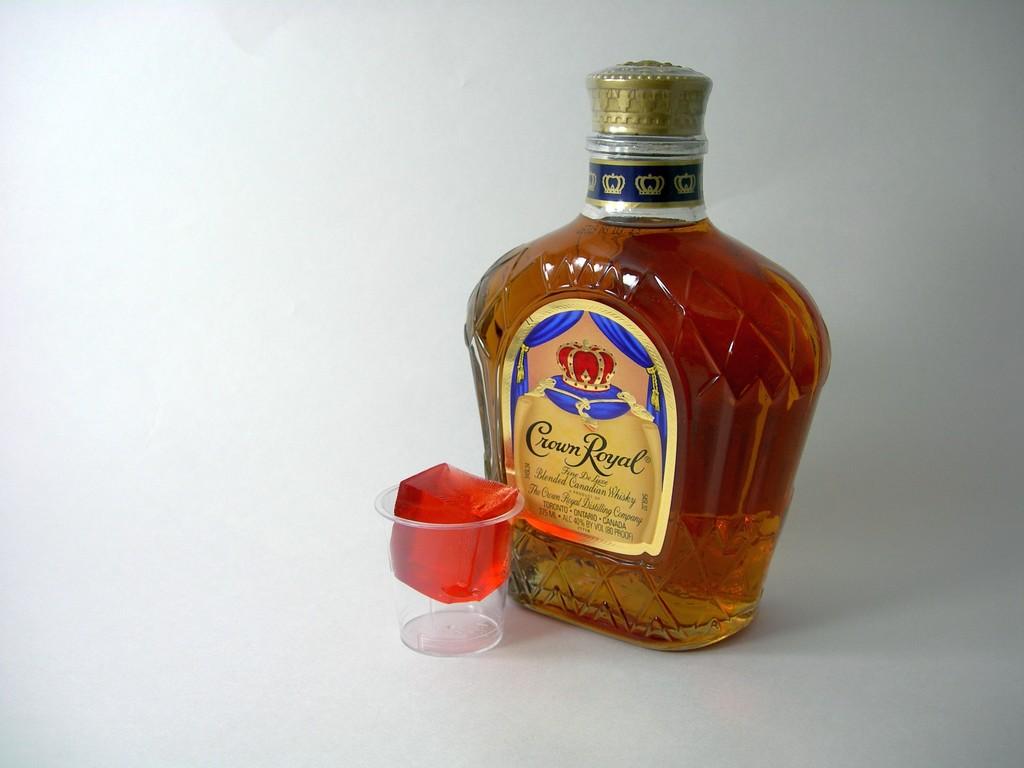What brand of whiskey is this?
Provide a short and direct response. Crown royal. What kind of whisky is this?
Give a very brief answer. Crown royal. 